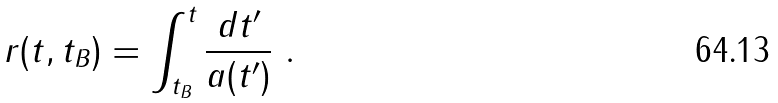Convert formula to latex. <formula><loc_0><loc_0><loc_500><loc_500>r ( t , t _ { B } ) = \int ^ { t } _ { t _ { B } } \frac { d t ^ { \prime } } { a ( t ^ { \prime } ) } \ .</formula> 